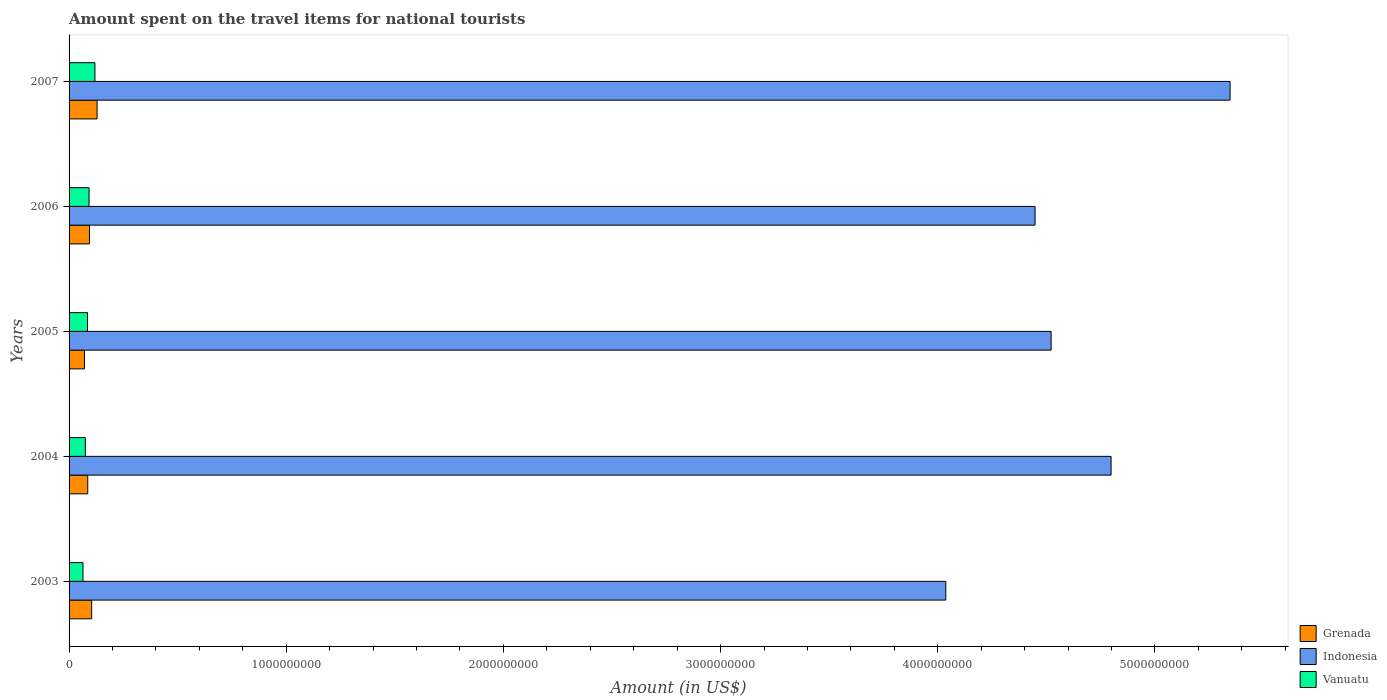Are the number of bars per tick equal to the number of legend labels?
Offer a terse response. Yes. Are the number of bars on each tick of the Y-axis equal?
Give a very brief answer. Yes. How many bars are there on the 2nd tick from the bottom?
Provide a succinct answer. 3. What is the amount spent on the travel items for national tourists in Vanuatu in 2006?
Ensure brevity in your answer.  9.20e+07. Across all years, what is the maximum amount spent on the travel items for national tourists in Vanuatu?
Your response must be concise. 1.19e+08. Across all years, what is the minimum amount spent on the travel items for national tourists in Grenada?
Your answer should be compact. 7.10e+07. In which year was the amount spent on the travel items for national tourists in Grenada maximum?
Offer a very short reply. 2007. What is the total amount spent on the travel items for national tourists in Indonesia in the graph?
Offer a very short reply. 2.32e+1. What is the difference between the amount spent on the travel items for national tourists in Vanuatu in 2003 and that in 2006?
Keep it short and to the point. -2.80e+07. What is the difference between the amount spent on the travel items for national tourists in Vanuatu in 2005 and the amount spent on the travel items for national tourists in Indonesia in 2007?
Offer a terse response. -5.26e+09. What is the average amount spent on the travel items for national tourists in Grenada per year?
Give a very brief answer. 9.68e+07. In the year 2006, what is the difference between the amount spent on the travel items for national tourists in Grenada and amount spent on the travel items for national tourists in Vanuatu?
Ensure brevity in your answer.  2.00e+06. In how many years, is the amount spent on the travel items for national tourists in Indonesia greater than 400000000 US$?
Your answer should be very brief. 5. What is the ratio of the amount spent on the travel items for national tourists in Vanuatu in 2005 to that in 2007?
Keep it short and to the point. 0.71. Is the amount spent on the travel items for national tourists in Indonesia in 2004 less than that in 2006?
Keep it short and to the point. No. Is the difference between the amount spent on the travel items for national tourists in Grenada in 2003 and 2006 greater than the difference between the amount spent on the travel items for national tourists in Vanuatu in 2003 and 2006?
Offer a very short reply. Yes. What is the difference between the highest and the second highest amount spent on the travel items for national tourists in Grenada?
Your response must be concise. 2.50e+07. What is the difference between the highest and the lowest amount spent on the travel items for national tourists in Indonesia?
Give a very brief answer. 1.31e+09. In how many years, is the amount spent on the travel items for national tourists in Indonesia greater than the average amount spent on the travel items for national tourists in Indonesia taken over all years?
Provide a short and direct response. 2. What does the 1st bar from the bottom in 2004 represents?
Offer a terse response. Grenada. How many bars are there?
Keep it short and to the point. 15. Are all the bars in the graph horizontal?
Offer a very short reply. Yes. How many years are there in the graph?
Your answer should be very brief. 5. Are the values on the major ticks of X-axis written in scientific E-notation?
Keep it short and to the point. No. How many legend labels are there?
Provide a succinct answer. 3. What is the title of the graph?
Your answer should be compact. Amount spent on the travel items for national tourists. What is the label or title of the Y-axis?
Ensure brevity in your answer.  Years. What is the Amount (in US$) of Grenada in 2003?
Keep it short and to the point. 1.04e+08. What is the Amount (in US$) in Indonesia in 2003?
Give a very brief answer. 4.04e+09. What is the Amount (in US$) in Vanuatu in 2003?
Your answer should be very brief. 6.40e+07. What is the Amount (in US$) of Grenada in 2004?
Make the answer very short. 8.60e+07. What is the Amount (in US$) of Indonesia in 2004?
Ensure brevity in your answer.  4.80e+09. What is the Amount (in US$) in Vanuatu in 2004?
Your answer should be very brief. 7.50e+07. What is the Amount (in US$) of Grenada in 2005?
Your answer should be very brief. 7.10e+07. What is the Amount (in US$) in Indonesia in 2005?
Keep it short and to the point. 4.52e+09. What is the Amount (in US$) in Vanuatu in 2005?
Give a very brief answer. 8.50e+07. What is the Amount (in US$) in Grenada in 2006?
Provide a short and direct response. 9.40e+07. What is the Amount (in US$) in Indonesia in 2006?
Your response must be concise. 4.45e+09. What is the Amount (in US$) in Vanuatu in 2006?
Keep it short and to the point. 9.20e+07. What is the Amount (in US$) in Grenada in 2007?
Your answer should be very brief. 1.29e+08. What is the Amount (in US$) in Indonesia in 2007?
Your answer should be very brief. 5.35e+09. What is the Amount (in US$) in Vanuatu in 2007?
Keep it short and to the point. 1.19e+08. Across all years, what is the maximum Amount (in US$) of Grenada?
Offer a terse response. 1.29e+08. Across all years, what is the maximum Amount (in US$) of Indonesia?
Provide a succinct answer. 5.35e+09. Across all years, what is the maximum Amount (in US$) of Vanuatu?
Provide a succinct answer. 1.19e+08. Across all years, what is the minimum Amount (in US$) of Grenada?
Your answer should be very brief. 7.10e+07. Across all years, what is the minimum Amount (in US$) of Indonesia?
Your answer should be compact. 4.04e+09. Across all years, what is the minimum Amount (in US$) of Vanuatu?
Provide a short and direct response. 6.40e+07. What is the total Amount (in US$) of Grenada in the graph?
Your answer should be very brief. 4.84e+08. What is the total Amount (in US$) of Indonesia in the graph?
Provide a succinct answer. 2.32e+1. What is the total Amount (in US$) of Vanuatu in the graph?
Ensure brevity in your answer.  4.35e+08. What is the difference between the Amount (in US$) in Grenada in 2003 and that in 2004?
Provide a short and direct response. 1.80e+07. What is the difference between the Amount (in US$) of Indonesia in 2003 and that in 2004?
Ensure brevity in your answer.  -7.61e+08. What is the difference between the Amount (in US$) of Vanuatu in 2003 and that in 2004?
Offer a terse response. -1.10e+07. What is the difference between the Amount (in US$) in Grenada in 2003 and that in 2005?
Provide a short and direct response. 3.30e+07. What is the difference between the Amount (in US$) in Indonesia in 2003 and that in 2005?
Ensure brevity in your answer.  -4.85e+08. What is the difference between the Amount (in US$) in Vanuatu in 2003 and that in 2005?
Your answer should be compact. -2.10e+07. What is the difference between the Amount (in US$) in Indonesia in 2003 and that in 2006?
Provide a short and direct response. -4.11e+08. What is the difference between the Amount (in US$) in Vanuatu in 2003 and that in 2006?
Provide a succinct answer. -2.80e+07. What is the difference between the Amount (in US$) of Grenada in 2003 and that in 2007?
Offer a terse response. -2.50e+07. What is the difference between the Amount (in US$) of Indonesia in 2003 and that in 2007?
Provide a succinct answer. -1.31e+09. What is the difference between the Amount (in US$) of Vanuatu in 2003 and that in 2007?
Provide a short and direct response. -5.50e+07. What is the difference between the Amount (in US$) in Grenada in 2004 and that in 2005?
Your answer should be very brief. 1.50e+07. What is the difference between the Amount (in US$) in Indonesia in 2004 and that in 2005?
Provide a short and direct response. 2.76e+08. What is the difference between the Amount (in US$) in Vanuatu in 2004 and that in 2005?
Your answer should be very brief. -1.00e+07. What is the difference between the Amount (in US$) of Grenada in 2004 and that in 2006?
Your response must be concise. -8.00e+06. What is the difference between the Amount (in US$) of Indonesia in 2004 and that in 2006?
Provide a succinct answer. 3.50e+08. What is the difference between the Amount (in US$) of Vanuatu in 2004 and that in 2006?
Give a very brief answer. -1.70e+07. What is the difference between the Amount (in US$) of Grenada in 2004 and that in 2007?
Keep it short and to the point. -4.30e+07. What is the difference between the Amount (in US$) of Indonesia in 2004 and that in 2007?
Ensure brevity in your answer.  -5.48e+08. What is the difference between the Amount (in US$) of Vanuatu in 2004 and that in 2007?
Make the answer very short. -4.40e+07. What is the difference between the Amount (in US$) of Grenada in 2005 and that in 2006?
Provide a succinct answer. -2.30e+07. What is the difference between the Amount (in US$) in Indonesia in 2005 and that in 2006?
Ensure brevity in your answer.  7.40e+07. What is the difference between the Amount (in US$) in Vanuatu in 2005 and that in 2006?
Provide a short and direct response. -7.00e+06. What is the difference between the Amount (in US$) of Grenada in 2005 and that in 2007?
Your answer should be very brief. -5.80e+07. What is the difference between the Amount (in US$) in Indonesia in 2005 and that in 2007?
Offer a terse response. -8.24e+08. What is the difference between the Amount (in US$) of Vanuatu in 2005 and that in 2007?
Your answer should be very brief. -3.40e+07. What is the difference between the Amount (in US$) in Grenada in 2006 and that in 2007?
Make the answer very short. -3.50e+07. What is the difference between the Amount (in US$) in Indonesia in 2006 and that in 2007?
Give a very brief answer. -8.98e+08. What is the difference between the Amount (in US$) in Vanuatu in 2006 and that in 2007?
Provide a short and direct response. -2.70e+07. What is the difference between the Amount (in US$) in Grenada in 2003 and the Amount (in US$) in Indonesia in 2004?
Your answer should be very brief. -4.69e+09. What is the difference between the Amount (in US$) of Grenada in 2003 and the Amount (in US$) of Vanuatu in 2004?
Make the answer very short. 2.90e+07. What is the difference between the Amount (in US$) in Indonesia in 2003 and the Amount (in US$) in Vanuatu in 2004?
Make the answer very short. 3.96e+09. What is the difference between the Amount (in US$) in Grenada in 2003 and the Amount (in US$) in Indonesia in 2005?
Offer a terse response. -4.42e+09. What is the difference between the Amount (in US$) of Grenada in 2003 and the Amount (in US$) of Vanuatu in 2005?
Ensure brevity in your answer.  1.90e+07. What is the difference between the Amount (in US$) in Indonesia in 2003 and the Amount (in US$) in Vanuatu in 2005?
Ensure brevity in your answer.  3.95e+09. What is the difference between the Amount (in US$) of Grenada in 2003 and the Amount (in US$) of Indonesia in 2006?
Ensure brevity in your answer.  -4.34e+09. What is the difference between the Amount (in US$) in Indonesia in 2003 and the Amount (in US$) in Vanuatu in 2006?
Offer a terse response. 3.94e+09. What is the difference between the Amount (in US$) of Grenada in 2003 and the Amount (in US$) of Indonesia in 2007?
Give a very brief answer. -5.24e+09. What is the difference between the Amount (in US$) in Grenada in 2003 and the Amount (in US$) in Vanuatu in 2007?
Offer a very short reply. -1.50e+07. What is the difference between the Amount (in US$) of Indonesia in 2003 and the Amount (in US$) of Vanuatu in 2007?
Your answer should be very brief. 3.92e+09. What is the difference between the Amount (in US$) of Grenada in 2004 and the Amount (in US$) of Indonesia in 2005?
Your response must be concise. -4.44e+09. What is the difference between the Amount (in US$) in Grenada in 2004 and the Amount (in US$) in Vanuatu in 2005?
Provide a short and direct response. 1.00e+06. What is the difference between the Amount (in US$) in Indonesia in 2004 and the Amount (in US$) in Vanuatu in 2005?
Provide a short and direct response. 4.71e+09. What is the difference between the Amount (in US$) in Grenada in 2004 and the Amount (in US$) in Indonesia in 2006?
Your answer should be compact. -4.36e+09. What is the difference between the Amount (in US$) of Grenada in 2004 and the Amount (in US$) of Vanuatu in 2006?
Your answer should be compact. -6.00e+06. What is the difference between the Amount (in US$) in Indonesia in 2004 and the Amount (in US$) in Vanuatu in 2006?
Your response must be concise. 4.71e+09. What is the difference between the Amount (in US$) of Grenada in 2004 and the Amount (in US$) of Indonesia in 2007?
Give a very brief answer. -5.26e+09. What is the difference between the Amount (in US$) of Grenada in 2004 and the Amount (in US$) of Vanuatu in 2007?
Your answer should be compact. -3.30e+07. What is the difference between the Amount (in US$) of Indonesia in 2004 and the Amount (in US$) of Vanuatu in 2007?
Ensure brevity in your answer.  4.68e+09. What is the difference between the Amount (in US$) in Grenada in 2005 and the Amount (in US$) in Indonesia in 2006?
Your response must be concise. -4.38e+09. What is the difference between the Amount (in US$) in Grenada in 2005 and the Amount (in US$) in Vanuatu in 2006?
Make the answer very short. -2.10e+07. What is the difference between the Amount (in US$) in Indonesia in 2005 and the Amount (in US$) in Vanuatu in 2006?
Your answer should be compact. 4.43e+09. What is the difference between the Amount (in US$) of Grenada in 2005 and the Amount (in US$) of Indonesia in 2007?
Your response must be concise. -5.28e+09. What is the difference between the Amount (in US$) in Grenada in 2005 and the Amount (in US$) in Vanuatu in 2007?
Provide a succinct answer. -4.80e+07. What is the difference between the Amount (in US$) of Indonesia in 2005 and the Amount (in US$) of Vanuatu in 2007?
Keep it short and to the point. 4.40e+09. What is the difference between the Amount (in US$) in Grenada in 2006 and the Amount (in US$) in Indonesia in 2007?
Keep it short and to the point. -5.25e+09. What is the difference between the Amount (in US$) of Grenada in 2006 and the Amount (in US$) of Vanuatu in 2007?
Offer a terse response. -2.50e+07. What is the difference between the Amount (in US$) in Indonesia in 2006 and the Amount (in US$) in Vanuatu in 2007?
Offer a terse response. 4.33e+09. What is the average Amount (in US$) of Grenada per year?
Offer a very short reply. 9.68e+07. What is the average Amount (in US$) of Indonesia per year?
Offer a very short reply. 4.63e+09. What is the average Amount (in US$) of Vanuatu per year?
Ensure brevity in your answer.  8.70e+07. In the year 2003, what is the difference between the Amount (in US$) of Grenada and Amount (in US$) of Indonesia?
Ensure brevity in your answer.  -3.93e+09. In the year 2003, what is the difference between the Amount (in US$) in Grenada and Amount (in US$) in Vanuatu?
Your answer should be compact. 4.00e+07. In the year 2003, what is the difference between the Amount (in US$) in Indonesia and Amount (in US$) in Vanuatu?
Offer a terse response. 3.97e+09. In the year 2004, what is the difference between the Amount (in US$) of Grenada and Amount (in US$) of Indonesia?
Your answer should be very brief. -4.71e+09. In the year 2004, what is the difference between the Amount (in US$) of Grenada and Amount (in US$) of Vanuatu?
Give a very brief answer. 1.10e+07. In the year 2004, what is the difference between the Amount (in US$) of Indonesia and Amount (in US$) of Vanuatu?
Provide a short and direct response. 4.72e+09. In the year 2005, what is the difference between the Amount (in US$) in Grenada and Amount (in US$) in Indonesia?
Provide a succinct answer. -4.45e+09. In the year 2005, what is the difference between the Amount (in US$) in Grenada and Amount (in US$) in Vanuatu?
Make the answer very short. -1.40e+07. In the year 2005, what is the difference between the Amount (in US$) of Indonesia and Amount (in US$) of Vanuatu?
Offer a terse response. 4.44e+09. In the year 2006, what is the difference between the Amount (in US$) of Grenada and Amount (in US$) of Indonesia?
Your answer should be compact. -4.35e+09. In the year 2006, what is the difference between the Amount (in US$) of Grenada and Amount (in US$) of Vanuatu?
Offer a very short reply. 2.00e+06. In the year 2006, what is the difference between the Amount (in US$) in Indonesia and Amount (in US$) in Vanuatu?
Provide a short and direct response. 4.36e+09. In the year 2007, what is the difference between the Amount (in US$) of Grenada and Amount (in US$) of Indonesia?
Provide a succinct answer. -5.22e+09. In the year 2007, what is the difference between the Amount (in US$) of Indonesia and Amount (in US$) of Vanuatu?
Offer a very short reply. 5.23e+09. What is the ratio of the Amount (in US$) of Grenada in 2003 to that in 2004?
Offer a very short reply. 1.21. What is the ratio of the Amount (in US$) of Indonesia in 2003 to that in 2004?
Provide a succinct answer. 0.84. What is the ratio of the Amount (in US$) of Vanuatu in 2003 to that in 2004?
Offer a very short reply. 0.85. What is the ratio of the Amount (in US$) in Grenada in 2003 to that in 2005?
Offer a terse response. 1.46. What is the ratio of the Amount (in US$) of Indonesia in 2003 to that in 2005?
Your answer should be very brief. 0.89. What is the ratio of the Amount (in US$) of Vanuatu in 2003 to that in 2005?
Provide a succinct answer. 0.75. What is the ratio of the Amount (in US$) in Grenada in 2003 to that in 2006?
Your answer should be compact. 1.11. What is the ratio of the Amount (in US$) of Indonesia in 2003 to that in 2006?
Give a very brief answer. 0.91. What is the ratio of the Amount (in US$) of Vanuatu in 2003 to that in 2006?
Give a very brief answer. 0.7. What is the ratio of the Amount (in US$) in Grenada in 2003 to that in 2007?
Keep it short and to the point. 0.81. What is the ratio of the Amount (in US$) of Indonesia in 2003 to that in 2007?
Offer a terse response. 0.76. What is the ratio of the Amount (in US$) of Vanuatu in 2003 to that in 2007?
Give a very brief answer. 0.54. What is the ratio of the Amount (in US$) of Grenada in 2004 to that in 2005?
Make the answer very short. 1.21. What is the ratio of the Amount (in US$) of Indonesia in 2004 to that in 2005?
Your answer should be very brief. 1.06. What is the ratio of the Amount (in US$) in Vanuatu in 2004 to that in 2005?
Your answer should be compact. 0.88. What is the ratio of the Amount (in US$) of Grenada in 2004 to that in 2006?
Your answer should be very brief. 0.91. What is the ratio of the Amount (in US$) of Indonesia in 2004 to that in 2006?
Your answer should be very brief. 1.08. What is the ratio of the Amount (in US$) of Vanuatu in 2004 to that in 2006?
Give a very brief answer. 0.82. What is the ratio of the Amount (in US$) of Indonesia in 2004 to that in 2007?
Your answer should be compact. 0.9. What is the ratio of the Amount (in US$) of Vanuatu in 2004 to that in 2007?
Provide a succinct answer. 0.63. What is the ratio of the Amount (in US$) in Grenada in 2005 to that in 2006?
Your answer should be compact. 0.76. What is the ratio of the Amount (in US$) of Indonesia in 2005 to that in 2006?
Your response must be concise. 1.02. What is the ratio of the Amount (in US$) in Vanuatu in 2005 to that in 2006?
Your answer should be very brief. 0.92. What is the ratio of the Amount (in US$) in Grenada in 2005 to that in 2007?
Your response must be concise. 0.55. What is the ratio of the Amount (in US$) of Indonesia in 2005 to that in 2007?
Your response must be concise. 0.85. What is the ratio of the Amount (in US$) in Grenada in 2006 to that in 2007?
Give a very brief answer. 0.73. What is the ratio of the Amount (in US$) in Indonesia in 2006 to that in 2007?
Keep it short and to the point. 0.83. What is the ratio of the Amount (in US$) of Vanuatu in 2006 to that in 2007?
Make the answer very short. 0.77. What is the difference between the highest and the second highest Amount (in US$) in Grenada?
Your response must be concise. 2.50e+07. What is the difference between the highest and the second highest Amount (in US$) in Indonesia?
Your answer should be very brief. 5.48e+08. What is the difference between the highest and the second highest Amount (in US$) in Vanuatu?
Offer a terse response. 2.70e+07. What is the difference between the highest and the lowest Amount (in US$) in Grenada?
Your answer should be compact. 5.80e+07. What is the difference between the highest and the lowest Amount (in US$) in Indonesia?
Your answer should be very brief. 1.31e+09. What is the difference between the highest and the lowest Amount (in US$) of Vanuatu?
Your answer should be very brief. 5.50e+07. 